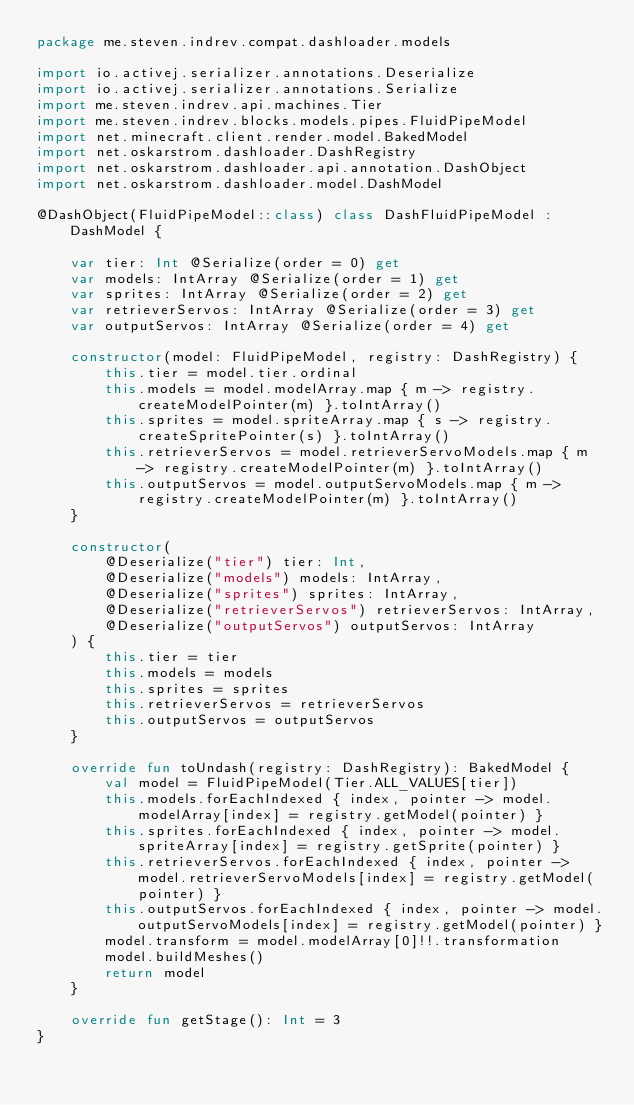Convert code to text. <code><loc_0><loc_0><loc_500><loc_500><_Kotlin_>package me.steven.indrev.compat.dashloader.models

import io.activej.serializer.annotations.Deserialize
import io.activej.serializer.annotations.Serialize
import me.steven.indrev.api.machines.Tier
import me.steven.indrev.blocks.models.pipes.FluidPipeModel
import net.minecraft.client.render.model.BakedModel
import net.oskarstrom.dashloader.DashRegistry
import net.oskarstrom.dashloader.api.annotation.DashObject
import net.oskarstrom.dashloader.model.DashModel

@DashObject(FluidPipeModel::class) class DashFluidPipeModel : DashModel {

    var tier: Int @Serialize(order = 0) get
    var models: IntArray @Serialize(order = 1) get
    var sprites: IntArray @Serialize(order = 2) get
    var retrieverServos: IntArray @Serialize(order = 3) get
    var outputServos: IntArray @Serialize(order = 4) get

    constructor(model: FluidPipeModel, registry: DashRegistry) {
        this.tier = model.tier.ordinal
        this.models = model.modelArray.map { m -> registry.createModelPointer(m) }.toIntArray()
        this.sprites = model.spriteArray.map { s -> registry.createSpritePointer(s) }.toIntArray()
        this.retrieverServos = model.retrieverServoModels.map { m -> registry.createModelPointer(m) }.toIntArray()
        this.outputServos = model.outputServoModels.map { m -> registry.createModelPointer(m) }.toIntArray()
    }

    constructor(
        @Deserialize("tier") tier: Int,
        @Deserialize("models") models: IntArray,
        @Deserialize("sprites") sprites: IntArray,
        @Deserialize("retrieverServos") retrieverServos: IntArray,
        @Deserialize("outputServos") outputServos: IntArray
    ) {
        this.tier = tier
        this.models = models
        this.sprites = sprites
        this.retrieverServos = retrieverServos
        this.outputServos = outputServos
    }

    override fun toUndash(registry: DashRegistry): BakedModel {
        val model = FluidPipeModel(Tier.ALL_VALUES[tier])
        this.models.forEachIndexed { index, pointer -> model.modelArray[index] = registry.getModel(pointer) }
        this.sprites.forEachIndexed { index, pointer -> model.spriteArray[index] = registry.getSprite(pointer) }
        this.retrieverServos.forEachIndexed { index, pointer -> model.retrieverServoModels[index] = registry.getModel(pointer) }
        this.outputServos.forEachIndexed { index, pointer -> model.outputServoModels[index] = registry.getModel(pointer) }
        model.transform = model.modelArray[0]!!.transformation
        model.buildMeshes()
        return model
    }

    override fun getStage(): Int = 3
}</code> 